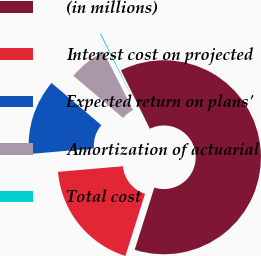Convert chart. <chart><loc_0><loc_0><loc_500><loc_500><pie_chart><fcel>(in millions)<fcel>Interest cost on projected<fcel>Expected return on plans'<fcel>Amortization of actuarial<fcel>Total cost<nl><fcel>62.17%<fcel>18.76%<fcel>12.56%<fcel>6.36%<fcel>0.15%<nl></chart> 